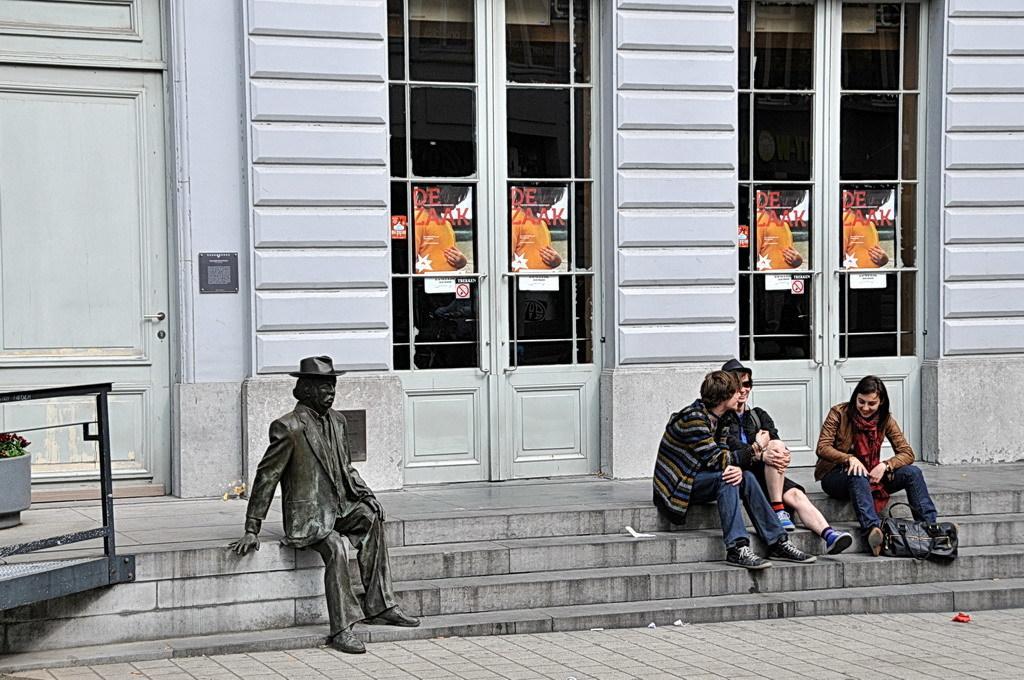In one or two sentences, can you explain what this image depicts? On the left side of the image we can see a statue, rods, pot, plants. On the right side of the image we can see some people are sitting on the stairs and also we can see a bag. In the background of the image we can see the doors, poster on the doors, wall. At the bottom of the image we can see the stairs, pavement. 